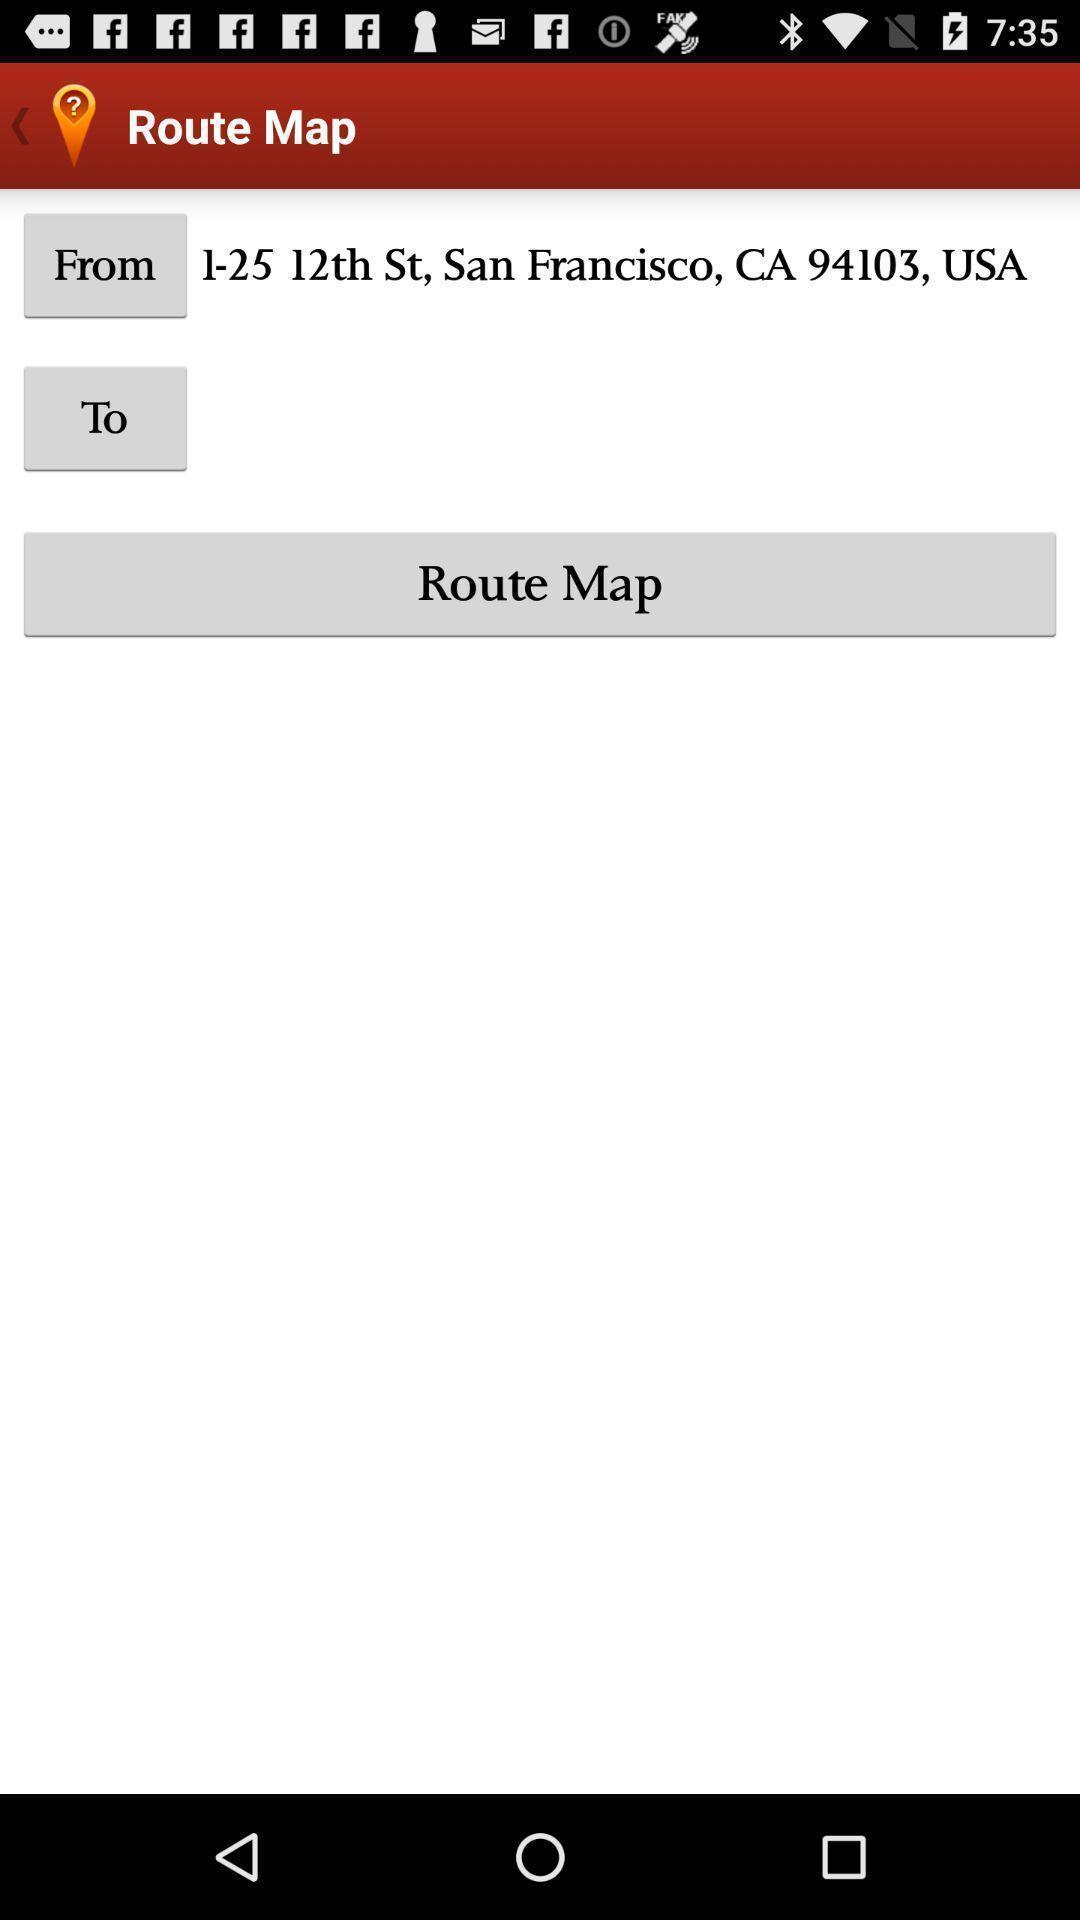Explain what's happening in this screen capture. Page with options to set location to route the map. 